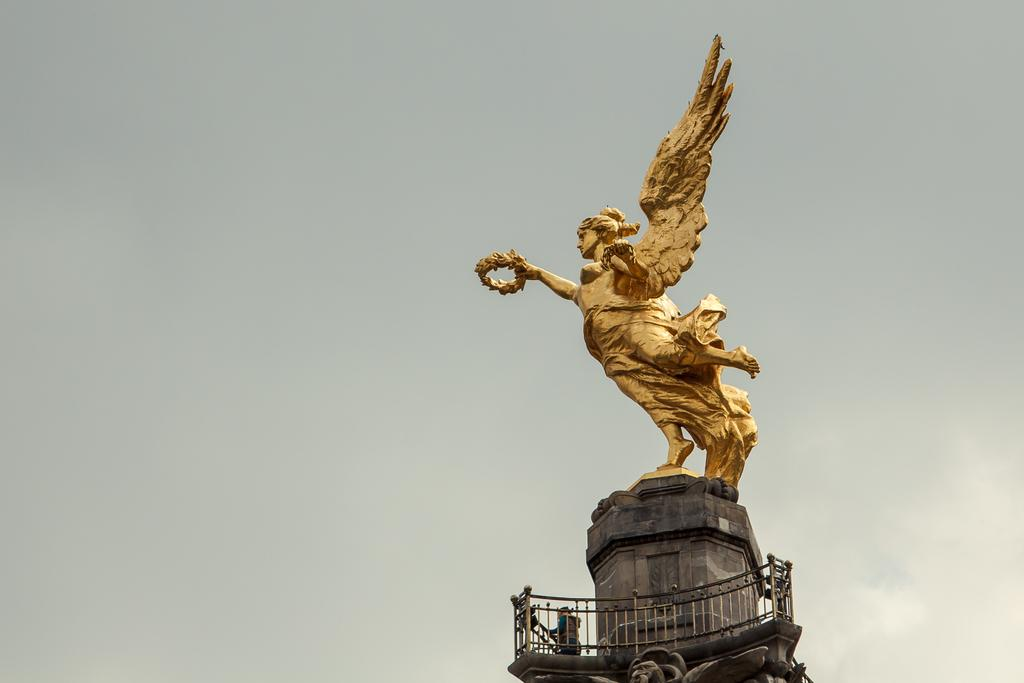What is the main subject in the image? There is a statue in the image. Where is the statue located in the image? The statue is towards the right side of the image. What colors can be seen on the statue? The statue is gold and grey in color. What can be seen in the background of the image? There is a sky visible in the background of the image. How many jellyfish are swimming in the sky in the image? There are no jellyfish present in the image, and the sky is not depicted as a body of water where jellyfish could swim. 